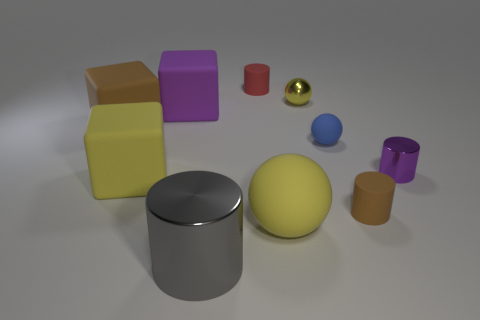What color is the block that is in front of the thing that is left of the big yellow block?
Keep it short and to the point. Yellow. Is the number of small brown matte cylinders that are to the right of the brown rubber cylinder the same as the number of tiny blue rubber balls?
Your answer should be very brief. No. Are there any gray objects that have the same size as the blue sphere?
Keep it short and to the point. No. There is a brown matte cylinder; is it the same size as the metal cylinder behind the large gray metal cylinder?
Provide a short and direct response. Yes. Are there the same number of tiny balls to the left of the small yellow shiny thing and yellow matte spheres on the left side of the big metallic thing?
Your answer should be compact. Yes. There is a large matte thing that is the same color as the big matte ball; what shape is it?
Give a very brief answer. Cube. There is a ball on the left side of the yellow metal thing; what is it made of?
Offer a terse response. Rubber. Does the gray shiny cylinder have the same size as the yellow shiny ball?
Keep it short and to the point. No. Are there more small shiny cylinders that are on the right side of the red cylinder than shiny blocks?
Offer a terse response. Yes. What size is the yellow sphere that is the same material as the purple cylinder?
Provide a succinct answer. Small. 